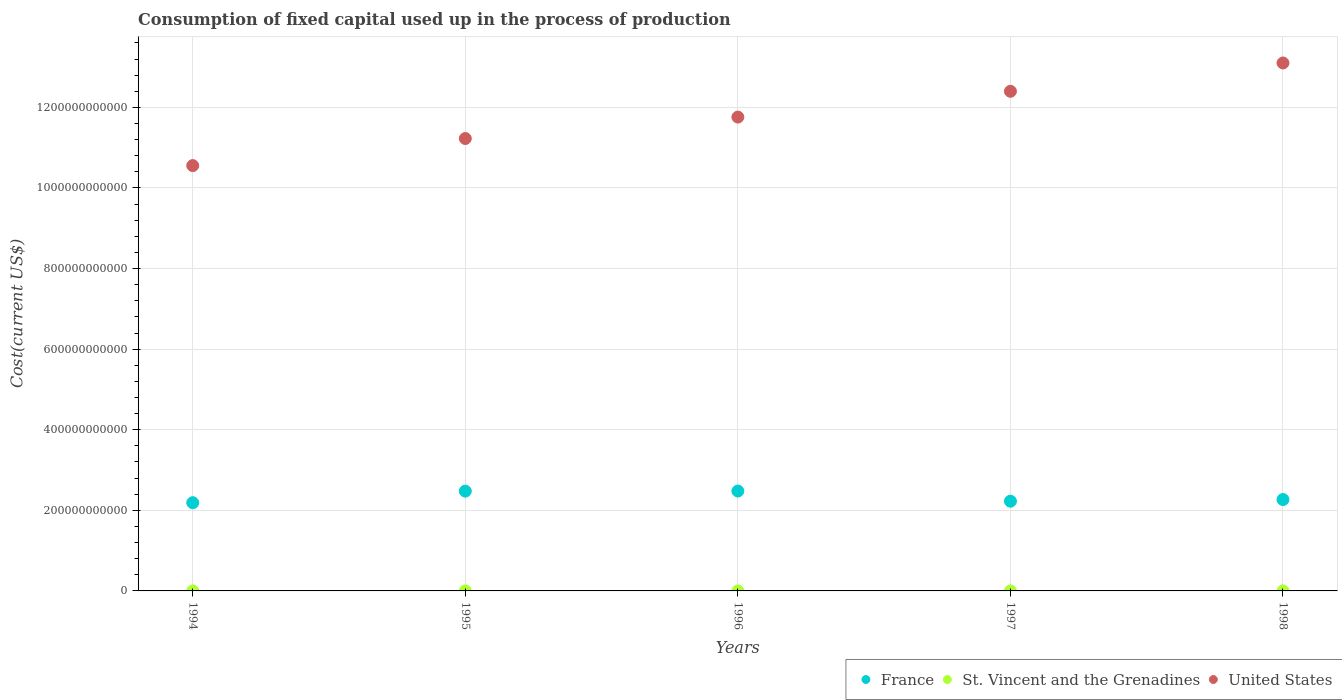How many different coloured dotlines are there?
Your answer should be very brief. 3. What is the amount consumed in the process of production in United States in 1997?
Offer a very short reply. 1.24e+12. Across all years, what is the maximum amount consumed in the process of production in St. Vincent and the Grenadines?
Keep it short and to the point. 1.01e+07. Across all years, what is the minimum amount consumed in the process of production in United States?
Provide a short and direct response. 1.06e+12. In which year was the amount consumed in the process of production in United States maximum?
Offer a very short reply. 1998. What is the total amount consumed in the process of production in France in the graph?
Provide a short and direct response. 1.16e+12. What is the difference between the amount consumed in the process of production in United States in 1994 and that in 1995?
Your answer should be very brief. -6.72e+1. What is the difference between the amount consumed in the process of production in France in 1995 and the amount consumed in the process of production in United States in 1996?
Your answer should be compact. -9.28e+11. What is the average amount consumed in the process of production in United States per year?
Give a very brief answer. 1.18e+12. In the year 1994, what is the difference between the amount consumed in the process of production in St. Vincent and the Grenadines and amount consumed in the process of production in United States?
Make the answer very short. -1.06e+12. What is the ratio of the amount consumed in the process of production in France in 1994 to that in 1996?
Give a very brief answer. 0.88. Is the difference between the amount consumed in the process of production in St. Vincent and the Grenadines in 1994 and 1996 greater than the difference between the amount consumed in the process of production in United States in 1994 and 1996?
Provide a succinct answer. Yes. What is the difference between the highest and the second highest amount consumed in the process of production in United States?
Keep it short and to the point. 7.03e+1. What is the difference between the highest and the lowest amount consumed in the process of production in St. Vincent and the Grenadines?
Give a very brief answer. 3.02e+06. Is it the case that in every year, the sum of the amount consumed in the process of production in St. Vincent and the Grenadines and amount consumed in the process of production in France  is greater than the amount consumed in the process of production in United States?
Keep it short and to the point. No. Is the amount consumed in the process of production in France strictly greater than the amount consumed in the process of production in St. Vincent and the Grenadines over the years?
Your response must be concise. Yes. What is the difference between two consecutive major ticks on the Y-axis?
Your response must be concise. 2.00e+11. Are the values on the major ticks of Y-axis written in scientific E-notation?
Your answer should be very brief. No. Does the graph contain any zero values?
Give a very brief answer. No. Does the graph contain grids?
Make the answer very short. Yes. Where does the legend appear in the graph?
Give a very brief answer. Bottom right. How many legend labels are there?
Ensure brevity in your answer.  3. How are the legend labels stacked?
Offer a terse response. Horizontal. What is the title of the graph?
Give a very brief answer. Consumption of fixed capital used up in the process of production. Does "Spain" appear as one of the legend labels in the graph?
Your answer should be very brief. No. What is the label or title of the X-axis?
Make the answer very short. Years. What is the label or title of the Y-axis?
Keep it short and to the point. Cost(current US$). What is the Cost(current US$) in France in 1994?
Provide a short and direct response. 2.19e+11. What is the Cost(current US$) in St. Vincent and the Grenadines in 1994?
Provide a short and direct response. 7.06e+06. What is the Cost(current US$) in United States in 1994?
Provide a short and direct response. 1.06e+12. What is the Cost(current US$) of France in 1995?
Keep it short and to the point. 2.48e+11. What is the Cost(current US$) of St. Vincent and the Grenadines in 1995?
Your answer should be very brief. 7.69e+06. What is the Cost(current US$) in United States in 1995?
Offer a terse response. 1.12e+12. What is the Cost(current US$) of France in 1996?
Your answer should be very brief. 2.48e+11. What is the Cost(current US$) in St. Vincent and the Grenadines in 1996?
Give a very brief answer. 8.33e+06. What is the Cost(current US$) of United States in 1996?
Give a very brief answer. 1.18e+12. What is the Cost(current US$) of France in 1997?
Ensure brevity in your answer.  2.23e+11. What is the Cost(current US$) of St. Vincent and the Grenadines in 1997?
Your answer should be compact. 8.71e+06. What is the Cost(current US$) in United States in 1997?
Ensure brevity in your answer.  1.24e+12. What is the Cost(current US$) in France in 1998?
Your answer should be compact. 2.27e+11. What is the Cost(current US$) of St. Vincent and the Grenadines in 1998?
Your response must be concise. 1.01e+07. What is the Cost(current US$) of United States in 1998?
Offer a very short reply. 1.31e+12. Across all years, what is the maximum Cost(current US$) in France?
Ensure brevity in your answer.  2.48e+11. Across all years, what is the maximum Cost(current US$) of St. Vincent and the Grenadines?
Provide a succinct answer. 1.01e+07. Across all years, what is the maximum Cost(current US$) of United States?
Your answer should be very brief. 1.31e+12. Across all years, what is the minimum Cost(current US$) in France?
Offer a terse response. 2.19e+11. Across all years, what is the minimum Cost(current US$) in St. Vincent and the Grenadines?
Your answer should be compact. 7.06e+06. Across all years, what is the minimum Cost(current US$) of United States?
Offer a terse response. 1.06e+12. What is the total Cost(current US$) in France in the graph?
Make the answer very short. 1.16e+12. What is the total Cost(current US$) of St. Vincent and the Grenadines in the graph?
Provide a succinct answer. 4.19e+07. What is the total Cost(current US$) of United States in the graph?
Provide a short and direct response. 5.90e+12. What is the difference between the Cost(current US$) in France in 1994 and that in 1995?
Your response must be concise. -2.87e+1. What is the difference between the Cost(current US$) of St. Vincent and the Grenadines in 1994 and that in 1995?
Your response must be concise. -6.26e+05. What is the difference between the Cost(current US$) of United States in 1994 and that in 1995?
Keep it short and to the point. -6.72e+1. What is the difference between the Cost(current US$) in France in 1994 and that in 1996?
Keep it short and to the point. -2.90e+1. What is the difference between the Cost(current US$) of St. Vincent and the Grenadines in 1994 and that in 1996?
Keep it short and to the point. -1.27e+06. What is the difference between the Cost(current US$) in United States in 1994 and that in 1996?
Your response must be concise. -1.20e+11. What is the difference between the Cost(current US$) of France in 1994 and that in 1997?
Provide a short and direct response. -3.75e+09. What is the difference between the Cost(current US$) in St. Vincent and the Grenadines in 1994 and that in 1997?
Make the answer very short. -1.65e+06. What is the difference between the Cost(current US$) of United States in 1994 and that in 1997?
Make the answer very short. -1.84e+11. What is the difference between the Cost(current US$) of France in 1994 and that in 1998?
Your answer should be very brief. -7.87e+09. What is the difference between the Cost(current US$) in St. Vincent and the Grenadines in 1994 and that in 1998?
Offer a terse response. -3.02e+06. What is the difference between the Cost(current US$) in United States in 1994 and that in 1998?
Offer a very short reply. -2.55e+11. What is the difference between the Cost(current US$) in France in 1995 and that in 1996?
Keep it short and to the point. -2.12e+08. What is the difference between the Cost(current US$) of St. Vincent and the Grenadines in 1995 and that in 1996?
Keep it short and to the point. -6.44e+05. What is the difference between the Cost(current US$) in United States in 1995 and that in 1996?
Offer a very short reply. -5.32e+1. What is the difference between the Cost(current US$) in France in 1995 and that in 1997?
Provide a short and direct response. 2.50e+1. What is the difference between the Cost(current US$) in St. Vincent and the Grenadines in 1995 and that in 1997?
Your response must be concise. -1.02e+06. What is the difference between the Cost(current US$) of United States in 1995 and that in 1997?
Give a very brief answer. -1.17e+11. What is the difference between the Cost(current US$) of France in 1995 and that in 1998?
Keep it short and to the point. 2.09e+1. What is the difference between the Cost(current US$) in St. Vincent and the Grenadines in 1995 and that in 1998?
Offer a terse response. -2.40e+06. What is the difference between the Cost(current US$) of United States in 1995 and that in 1998?
Your answer should be compact. -1.88e+11. What is the difference between the Cost(current US$) of France in 1996 and that in 1997?
Offer a terse response. 2.52e+1. What is the difference between the Cost(current US$) of St. Vincent and the Grenadines in 1996 and that in 1997?
Provide a succinct answer. -3.79e+05. What is the difference between the Cost(current US$) in United States in 1996 and that in 1997?
Give a very brief answer. -6.40e+1. What is the difference between the Cost(current US$) in France in 1996 and that in 1998?
Keep it short and to the point. 2.11e+1. What is the difference between the Cost(current US$) in St. Vincent and the Grenadines in 1996 and that in 1998?
Your answer should be compact. -1.75e+06. What is the difference between the Cost(current US$) of United States in 1996 and that in 1998?
Make the answer very short. -1.34e+11. What is the difference between the Cost(current US$) of France in 1997 and that in 1998?
Provide a short and direct response. -4.12e+09. What is the difference between the Cost(current US$) in St. Vincent and the Grenadines in 1997 and that in 1998?
Make the answer very short. -1.37e+06. What is the difference between the Cost(current US$) of United States in 1997 and that in 1998?
Keep it short and to the point. -7.03e+1. What is the difference between the Cost(current US$) in France in 1994 and the Cost(current US$) in St. Vincent and the Grenadines in 1995?
Keep it short and to the point. 2.19e+11. What is the difference between the Cost(current US$) of France in 1994 and the Cost(current US$) of United States in 1995?
Make the answer very short. -9.04e+11. What is the difference between the Cost(current US$) of St. Vincent and the Grenadines in 1994 and the Cost(current US$) of United States in 1995?
Your answer should be compact. -1.12e+12. What is the difference between the Cost(current US$) in France in 1994 and the Cost(current US$) in St. Vincent and the Grenadines in 1996?
Offer a terse response. 2.19e+11. What is the difference between the Cost(current US$) in France in 1994 and the Cost(current US$) in United States in 1996?
Give a very brief answer. -9.57e+11. What is the difference between the Cost(current US$) of St. Vincent and the Grenadines in 1994 and the Cost(current US$) of United States in 1996?
Your answer should be compact. -1.18e+12. What is the difference between the Cost(current US$) in France in 1994 and the Cost(current US$) in St. Vincent and the Grenadines in 1997?
Your response must be concise. 2.19e+11. What is the difference between the Cost(current US$) in France in 1994 and the Cost(current US$) in United States in 1997?
Your answer should be compact. -1.02e+12. What is the difference between the Cost(current US$) of St. Vincent and the Grenadines in 1994 and the Cost(current US$) of United States in 1997?
Provide a succinct answer. -1.24e+12. What is the difference between the Cost(current US$) in France in 1994 and the Cost(current US$) in St. Vincent and the Grenadines in 1998?
Offer a very short reply. 2.19e+11. What is the difference between the Cost(current US$) of France in 1994 and the Cost(current US$) of United States in 1998?
Keep it short and to the point. -1.09e+12. What is the difference between the Cost(current US$) in St. Vincent and the Grenadines in 1994 and the Cost(current US$) in United States in 1998?
Ensure brevity in your answer.  -1.31e+12. What is the difference between the Cost(current US$) of France in 1995 and the Cost(current US$) of St. Vincent and the Grenadines in 1996?
Offer a terse response. 2.48e+11. What is the difference between the Cost(current US$) in France in 1995 and the Cost(current US$) in United States in 1996?
Provide a succinct answer. -9.28e+11. What is the difference between the Cost(current US$) of St. Vincent and the Grenadines in 1995 and the Cost(current US$) of United States in 1996?
Your answer should be compact. -1.18e+12. What is the difference between the Cost(current US$) of France in 1995 and the Cost(current US$) of St. Vincent and the Grenadines in 1997?
Give a very brief answer. 2.48e+11. What is the difference between the Cost(current US$) of France in 1995 and the Cost(current US$) of United States in 1997?
Offer a terse response. -9.92e+11. What is the difference between the Cost(current US$) in St. Vincent and the Grenadines in 1995 and the Cost(current US$) in United States in 1997?
Provide a succinct answer. -1.24e+12. What is the difference between the Cost(current US$) of France in 1995 and the Cost(current US$) of St. Vincent and the Grenadines in 1998?
Make the answer very short. 2.48e+11. What is the difference between the Cost(current US$) in France in 1995 and the Cost(current US$) in United States in 1998?
Offer a terse response. -1.06e+12. What is the difference between the Cost(current US$) in St. Vincent and the Grenadines in 1995 and the Cost(current US$) in United States in 1998?
Offer a terse response. -1.31e+12. What is the difference between the Cost(current US$) in France in 1996 and the Cost(current US$) in St. Vincent and the Grenadines in 1997?
Keep it short and to the point. 2.48e+11. What is the difference between the Cost(current US$) of France in 1996 and the Cost(current US$) of United States in 1997?
Your answer should be very brief. -9.92e+11. What is the difference between the Cost(current US$) in St. Vincent and the Grenadines in 1996 and the Cost(current US$) in United States in 1997?
Keep it short and to the point. -1.24e+12. What is the difference between the Cost(current US$) in France in 1996 and the Cost(current US$) in St. Vincent and the Grenadines in 1998?
Keep it short and to the point. 2.48e+11. What is the difference between the Cost(current US$) of France in 1996 and the Cost(current US$) of United States in 1998?
Provide a short and direct response. -1.06e+12. What is the difference between the Cost(current US$) of St. Vincent and the Grenadines in 1996 and the Cost(current US$) of United States in 1998?
Make the answer very short. -1.31e+12. What is the difference between the Cost(current US$) of France in 1997 and the Cost(current US$) of St. Vincent and the Grenadines in 1998?
Make the answer very short. 2.23e+11. What is the difference between the Cost(current US$) of France in 1997 and the Cost(current US$) of United States in 1998?
Give a very brief answer. -1.09e+12. What is the difference between the Cost(current US$) in St. Vincent and the Grenadines in 1997 and the Cost(current US$) in United States in 1998?
Provide a short and direct response. -1.31e+12. What is the average Cost(current US$) of France per year?
Give a very brief answer. 2.33e+11. What is the average Cost(current US$) in St. Vincent and the Grenadines per year?
Make the answer very short. 8.38e+06. What is the average Cost(current US$) in United States per year?
Keep it short and to the point. 1.18e+12. In the year 1994, what is the difference between the Cost(current US$) in France and Cost(current US$) in St. Vincent and the Grenadines?
Provide a succinct answer. 2.19e+11. In the year 1994, what is the difference between the Cost(current US$) of France and Cost(current US$) of United States?
Keep it short and to the point. -8.37e+11. In the year 1994, what is the difference between the Cost(current US$) of St. Vincent and the Grenadines and Cost(current US$) of United States?
Provide a short and direct response. -1.06e+12. In the year 1995, what is the difference between the Cost(current US$) in France and Cost(current US$) in St. Vincent and the Grenadines?
Your response must be concise. 2.48e+11. In the year 1995, what is the difference between the Cost(current US$) of France and Cost(current US$) of United States?
Your response must be concise. -8.75e+11. In the year 1995, what is the difference between the Cost(current US$) in St. Vincent and the Grenadines and Cost(current US$) in United States?
Offer a very short reply. -1.12e+12. In the year 1996, what is the difference between the Cost(current US$) of France and Cost(current US$) of St. Vincent and the Grenadines?
Your answer should be compact. 2.48e+11. In the year 1996, what is the difference between the Cost(current US$) in France and Cost(current US$) in United States?
Offer a very short reply. -9.28e+11. In the year 1996, what is the difference between the Cost(current US$) of St. Vincent and the Grenadines and Cost(current US$) of United States?
Make the answer very short. -1.18e+12. In the year 1997, what is the difference between the Cost(current US$) in France and Cost(current US$) in St. Vincent and the Grenadines?
Your answer should be very brief. 2.23e+11. In the year 1997, what is the difference between the Cost(current US$) of France and Cost(current US$) of United States?
Give a very brief answer. -1.02e+12. In the year 1997, what is the difference between the Cost(current US$) of St. Vincent and the Grenadines and Cost(current US$) of United States?
Ensure brevity in your answer.  -1.24e+12. In the year 1998, what is the difference between the Cost(current US$) of France and Cost(current US$) of St. Vincent and the Grenadines?
Keep it short and to the point. 2.27e+11. In the year 1998, what is the difference between the Cost(current US$) of France and Cost(current US$) of United States?
Keep it short and to the point. -1.08e+12. In the year 1998, what is the difference between the Cost(current US$) in St. Vincent and the Grenadines and Cost(current US$) in United States?
Keep it short and to the point. -1.31e+12. What is the ratio of the Cost(current US$) of France in 1994 to that in 1995?
Give a very brief answer. 0.88. What is the ratio of the Cost(current US$) in St. Vincent and the Grenadines in 1994 to that in 1995?
Offer a terse response. 0.92. What is the ratio of the Cost(current US$) in United States in 1994 to that in 1995?
Your response must be concise. 0.94. What is the ratio of the Cost(current US$) of France in 1994 to that in 1996?
Your response must be concise. 0.88. What is the ratio of the Cost(current US$) in St. Vincent and the Grenadines in 1994 to that in 1996?
Keep it short and to the point. 0.85. What is the ratio of the Cost(current US$) in United States in 1994 to that in 1996?
Offer a very short reply. 0.9. What is the ratio of the Cost(current US$) in France in 1994 to that in 1997?
Give a very brief answer. 0.98. What is the ratio of the Cost(current US$) of St. Vincent and the Grenadines in 1994 to that in 1997?
Your response must be concise. 0.81. What is the ratio of the Cost(current US$) in United States in 1994 to that in 1997?
Provide a succinct answer. 0.85. What is the ratio of the Cost(current US$) of France in 1994 to that in 1998?
Provide a short and direct response. 0.97. What is the ratio of the Cost(current US$) in St. Vincent and the Grenadines in 1994 to that in 1998?
Provide a short and direct response. 0.7. What is the ratio of the Cost(current US$) of United States in 1994 to that in 1998?
Provide a short and direct response. 0.81. What is the ratio of the Cost(current US$) in France in 1995 to that in 1996?
Offer a very short reply. 1. What is the ratio of the Cost(current US$) of St. Vincent and the Grenadines in 1995 to that in 1996?
Keep it short and to the point. 0.92. What is the ratio of the Cost(current US$) of United States in 1995 to that in 1996?
Offer a very short reply. 0.95. What is the ratio of the Cost(current US$) in France in 1995 to that in 1997?
Provide a succinct answer. 1.11. What is the ratio of the Cost(current US$) in St. Vincent and the Grenadines in 1995 to that in 1997?
Ensure brevity in your answer.  0.88. What is the ratio of the Cost(current US$) in United States in 1995 to that in 1997?
Your answer should be compact. 0.91. What is the ratio of the Cost(current US$) in France in 1995 to that in 1998?
Your answer should be compact. 1.09. What is the ratio of the Cost(current US$) in St. Vincent and the Grenadines in 1995 to that in 1998?
Provide a succinct answer. 0.76. What is the ratio of the Cost(current US$) in United States in 1995 to that in 1998?
Provide a short and direct response. 0.86. What is the ratio of the Cost(current US$) in France in 1996 to that in 1997?
Make the answer very short. 1.11. What is the ratio of the Cost(current US$) of St. Vincent and the Grenadines in 1996 to that in 1997?
Ensure brevity in your answer.  0.96. What is the ratio of the Cost(current US$) in United States in 1996 to that in 1997?
Provide a succinct answer. 0.95. What is the ratio of the Cost(current US$) in France in 1996 to that in 1998?
Your response must be concise. 1.09. What is the ratio of the Cost(current US$) in St. Vincent and the Grenadines in 1996 to that in 1998?
Offer a very short reply. 0.83. What is the ratio of the Cost(current US$) in United States in 1996 to that in 1998?
Make the answer very short. 0.9. What is the ratio of the Cost(current US$) of France in 1997 to that in 1998?
Make the answer very short. 0.98. What is the ratio of the Cost(current US$) of St. Vincent and the Grenadines in 1997 to that in 1998?
Provide a short and direct response. 0.86. What is the ratio of the Cost(current US$) of United States in 1997 to that in 1998?
Your response must be concise. 0.95. What is the difference between the highest and the second highest Cost(current US$) of France?
Give a very brief answer. 2.12e+08. What is the difference between the highest and the second highest Cost(current US$) of St. Vincent and the Grenadines?
Your response must be concise. 1.37e+06. What is the difference between the highest and the second highest Cost(current US$) of United States?
Your answer should be very brief. 7.03e+1. What is the difference between the highest and the lowest Cost(current US$) in France?
Make the answer very short. 2.90e+1. What is the difference between the highest and the lowest Cost(current US$) of St. Vincent and the Grenadines?
Provide a short and direct response. 3.02e+06. What is the difference between the highest and the lowest Cost(current US$) of United States?
Offer a terse response. 2.55e+11. 